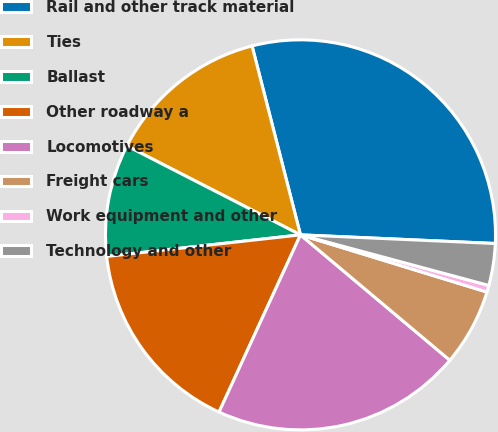<chart> <loc_0><loc_0><loc_500><loc_500><pie_chart><fcel>Rail and other track material<fcel>Ties<fcel>Ballast<fcel>Other roadway a<fcel>Locomotives<fcel>Freight cars<fcel>Work equipment and other<fcel>Technology and other<nl><fcel>29.7%<fcel>13.47%<fcel>9.3%<fcel>16.38%<fcel>20.74%<fcel>6.38%<fcel>0.56%<fcel>3.47%<nl></chart> 